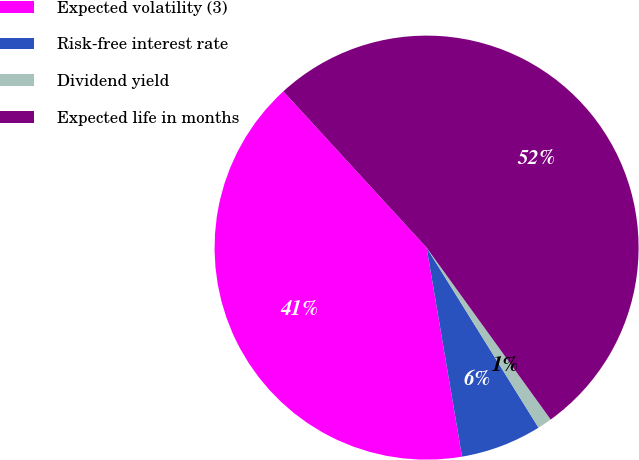Convert chart. <chart><loc_0><loc_0><loc_500><loc_500><pie_chart><fcel>Expected volatility (3)<fcel>Risk-free interest rate<fcel>Dividend yield<fcel>Expected life in months<nl><fcel>40.86%<fcel>6.18%<fcel>1.1%<fcel>51.86%<nl></chart> 